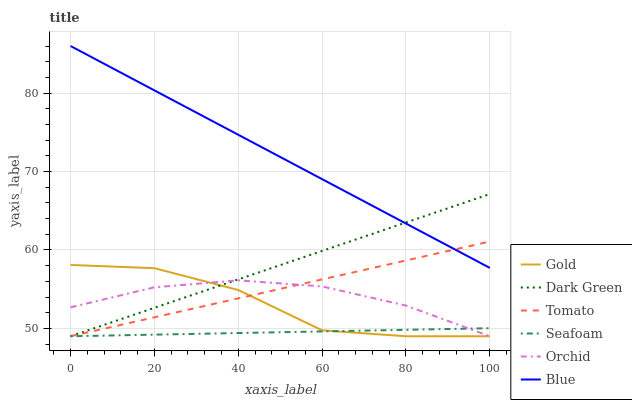Does Seafoam have the minimum area under the curve?
Answer yes or no. Yes. Does Blue have the maximum area under the curve?
Answer yes or no. Yes. Does Gold have the minimum area under the curve?
Answer yes or no. No. Does Gold have the maximum area under the curve?
Answer yes or no. No. Is Blue the smoothest?
Answer yes or no. Yes. Is Gold the roughest?
Answer yes or no. Yes. Is Gold the smoothest?
Answer yes or no. No. Is Blue the roughest?
Answer yes or no. No. Does Blue have the lowest value?
Answer yes or no. No. Does Blue have the highest value?
Answer yes or no. Yes. Does Gold have the highest value?
Answer yes or no. No. Is Orchid less than Blue?
Answer yes or no. Yes. Is Blue greater than Gold?
Answer yes or no. Yes. Does Tomato intersect Seafoam?
Answer yes or no. Yes. Is Tomato less than Seafoam?
Answer yes or no. No. Is Tomato greater than Seafoam?
Answer yes or no. No. Does Orchid intersect Blue?
Answer yes or no. No. 